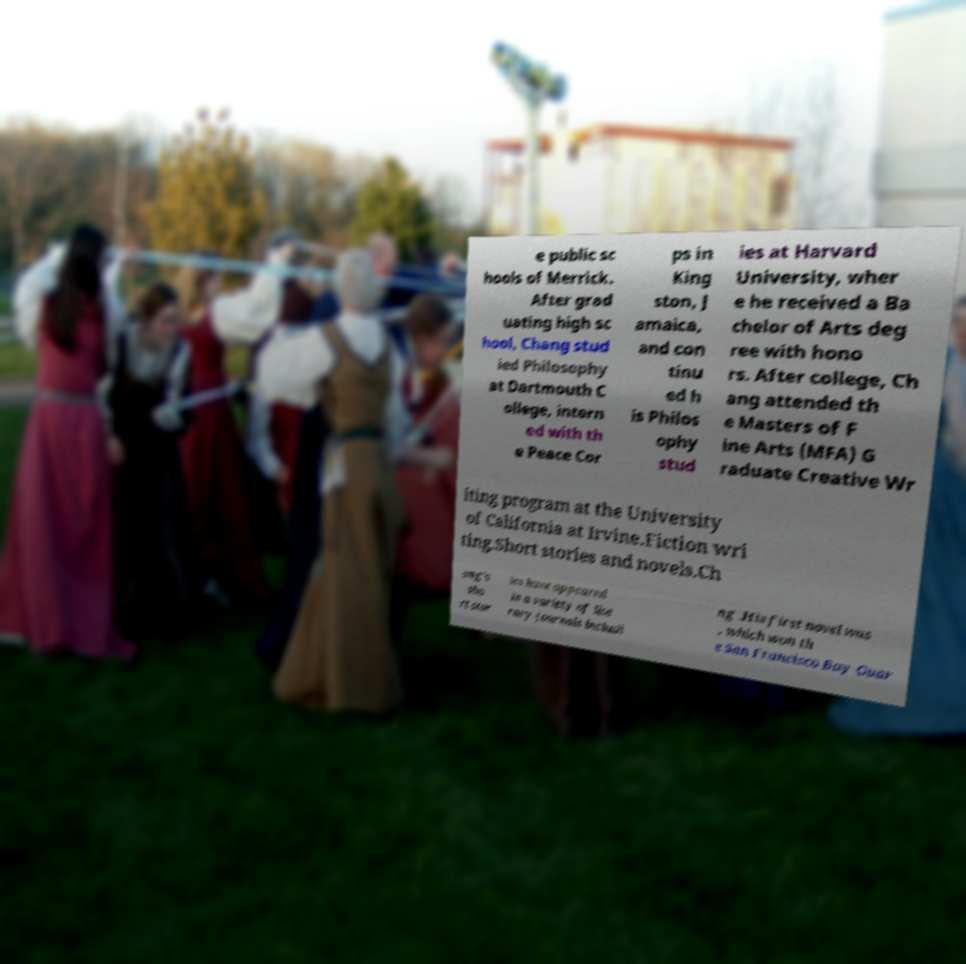What messages or text are displayed in this image? I need them in a readable, typed format. e public sc hools of Merrick. After grad uating high sc hool, Chang stud ied Philosophy at Dartmouth C ollege, intern ed with th e Peace Cor ps in King ston, J amaica, and con tinu ed h is Philos ophy stud ies at Harvard University, wher e he received a Ba chelor of Arts deg ree with hono rs. After college, Ch ang attended th e Masters of F ine Arts (MFA) G raduate Creative Wr iting program at the University of California at Irvine.Fiction wri ting.Short stories and novels.Ch ang's sho rt stor ies have appeared in a variety of lite rary journals includi ng .His first novel was , which won th e San Francisco Bay Guar 